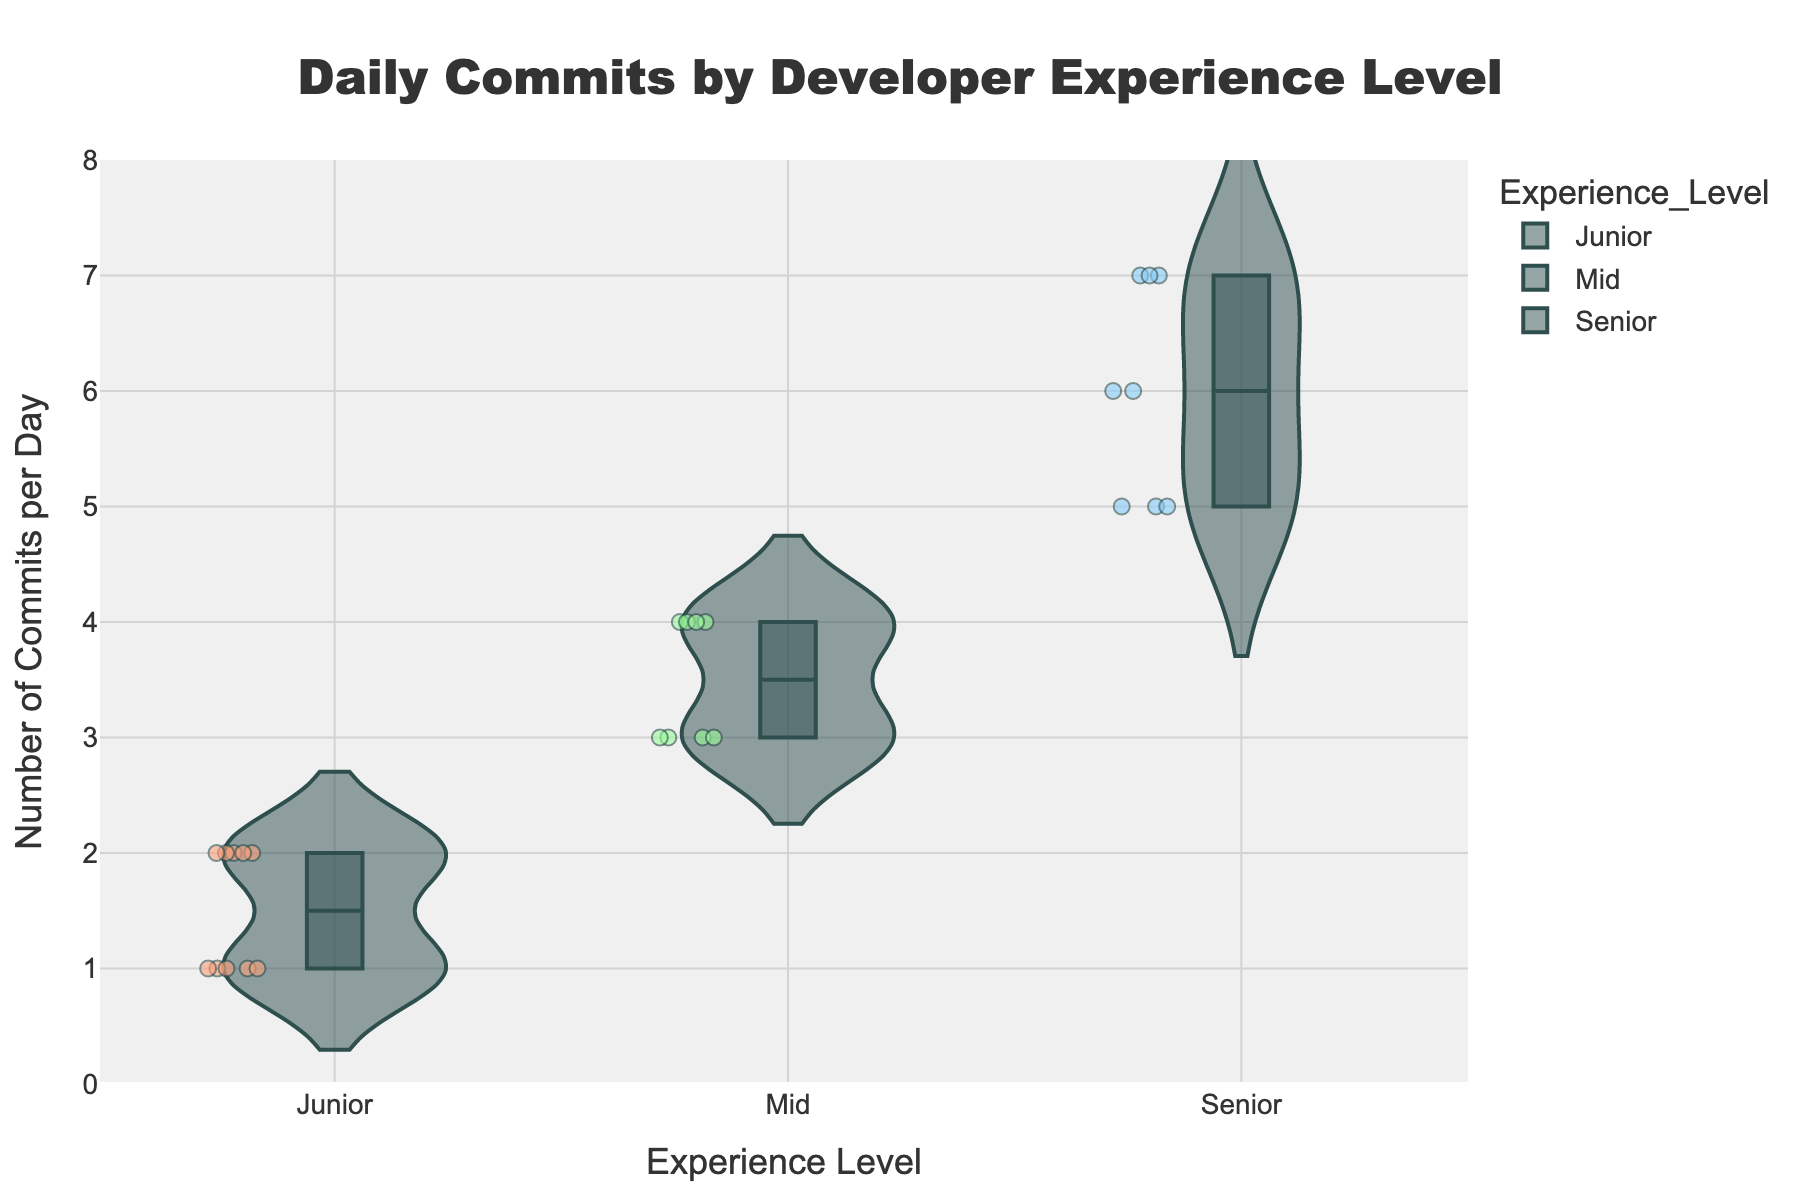How many experience levels are represented in the chart? The x-axis of the violin chart shows the different experience levels represented. From the figure, we can see three distinct categories: Junior, Mid, and Senior.
Answer: 3 What is the title of the chart? The title is displayed at the top of the figure in a large font. It reads "Daily Commits by Developer Experience Level".
Answer: Daily Commits by Developer Experience Level Which experience level has the highest median number of commits per day? The median is represented by the line within the box of each violin plot. The Senior experience level has the highest median, indicated by the line at the 6-commits mark.
Answer: Senior How many commits did the developer with the most commits in the Junior group make? The topmost jittered point in the Junior group represents the developer with the highest number of commits, which is 2 commits per day.
Answer: 2 Compare the spread of commits per day between Mid and Senior experience levels. The spread is indicated by the width of the violin plot and the range of jittered points. The Senior level has a broader spread as it ranges from 5 to 7 commits, while the Mid level ranges from 3 to 4 commits.
Answer: Senior has a broader spread What is the interquartile range (IQR) of commits per day for the Senior experience level? The IQR is indicated by the length of the box in the violin plot. For Seniors, the lower quartile is at 5, and the upper quartile is at 6, making the IQR 6 - 5 = 1.
Answer: 1 Which experience level shows the highest variability in commit frequency? Variability can be inferred from the spread and density of the violin plots and jittered points. Senior has the most variability, as it spans from 5 to 7 commits per day with a wide and densely filled plot.
Answer: Senior How does the number of commits per day for the most productive Junior developer compare to that of the least productive Senior developer? The most productive Junior developer has 2 commits per day, while the least productive Senior developer has 5 commits per day. The least productive Senior still has more commits than the most productive Junior.
Answer: Senior has more commits Identify the developer with the highest number of commits. By examining the highest points on the violin plots, the highest number of commits is 7 per day, found in the Senior group (e.g., Grace Wilson).
Answer: Grace Wilson What trends are noticeable between experience levels and number of commits per day? Each experience level shows a different range and density in their violin plots. Junior developers generally commit 1-2 times per day, Mid-level around 3-4, and Senior developers exhibit a larger range between 5-7 commits per day, indicating increased productivity with higher experience.
Answer: Increased productivity with higher experience 